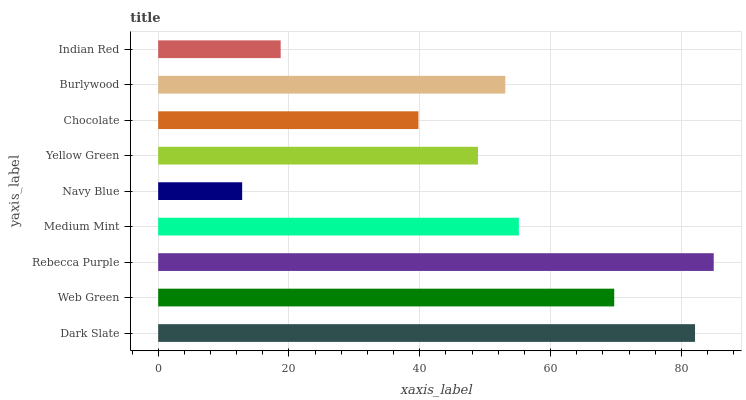Is Navy Blue the minimum?
Answer yes or no. Yes. Is Rebecca Purple the maximum?
Answer yes or no. Yes. Is Web Green the minimum?
Answer yes or no. No. Is Web Green the maximum?
Answer yes or no. No. Is Dark Slate greater than Web Green?
Answer yes or no. Yes. Is Web Green less than Dark Slate?
Answer yes or no. Yes. Is Web Green greater than Dark Slate?
Answer yes or no. No. Is Dark Slate less than Web Green?
Answer yes or no. No. Is Burlywood the high median?
Answer yes or no. Yes. Is Burlywood the low median?
Answer yes or no. Yes. Is Rebecca Purple the high median?
Answer yes or no. No. Is Dark Slate the low median?
Answer yes or no. No. 